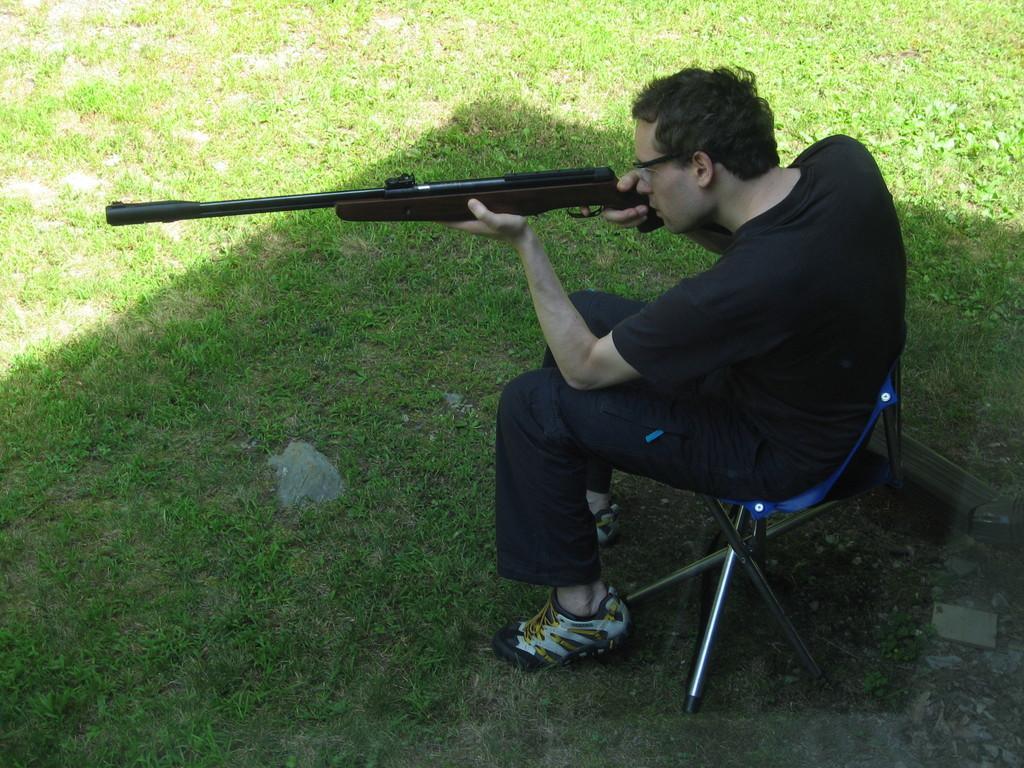Can you describe this image briefly? In this image I can see a person sitting on the chair and holding a gun in his hands. 